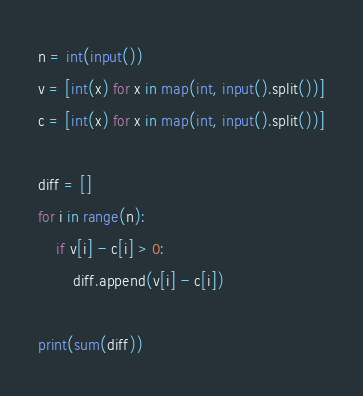Convert code to text. <code><loc_0><loc_0><loc_500><loc_500><_Python_>n = int(input())
v = [int(x) for x in map(int, input().split())]
c = [int(x) for x in map(int, input().split())]

diff = []
for i in range(n):
    if v[i] - c[i] > 0:
        diff.append(v[i] - c[i])

print(sum(diff))</code> 